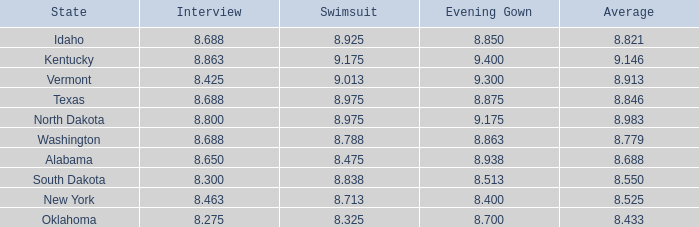425? None. Would you be able to parse every entry in this table? {'header': ['State', 'Interview', 'Swimsuit', 'Evening Gown', 'Average'], 'rows': [['Idaho', '8.688', '8.925', '8.850', '8.821'], ['Kentucky', '8.863', '9.175', '9.400', '9.146'], ['Vermont', '8.425', '9.013', '9.300', '8.913'], ['Texas', '8.688', '8.975', '8.875', '8.846'], ['North Dakota', '8.800', '8.975', '9.175', '8.983'], ['Washington', '8.688', '8.788', '8.863', '8.779'], ['Alabama', '8.650', '8.475', '8.938', '8.688'], ['South Dakota', '8.300', '8.838', '8.513', '8.550'], ['New York', '8.463', '8.713', '8.400', '8.525'], ['Oklahoma', '8.275', '8.325', '8.700', '8.433']]} 